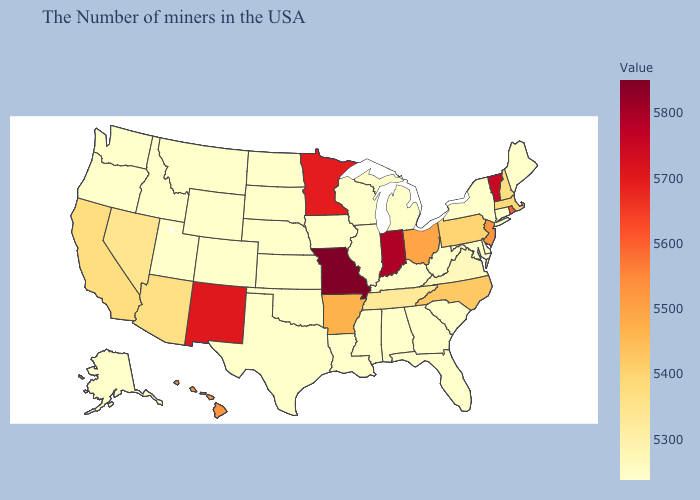Among the states that border Georgia , does Tennessee have the lowest value?
Write a very short answer. No. Does Minnesota have the lowest value in the MidWest?
Be succinct. No. Is the legend a continuous bar?
Give a very brief answer. Yes. Which states hav the highest value in the West?
Short answer required. New Mexico. Is the legend a continuous bar?
Be succinct. Yes. Does the map have missing data?
Short answer required. No. Which states have the lowest value in the South?
Quick response, please. Delaware, Maryland, South Carolina, West Virginia, Florida, Georgia, Kentucky, Alabama, Mississippi, Louisiana, Oklahoma, Texas. 